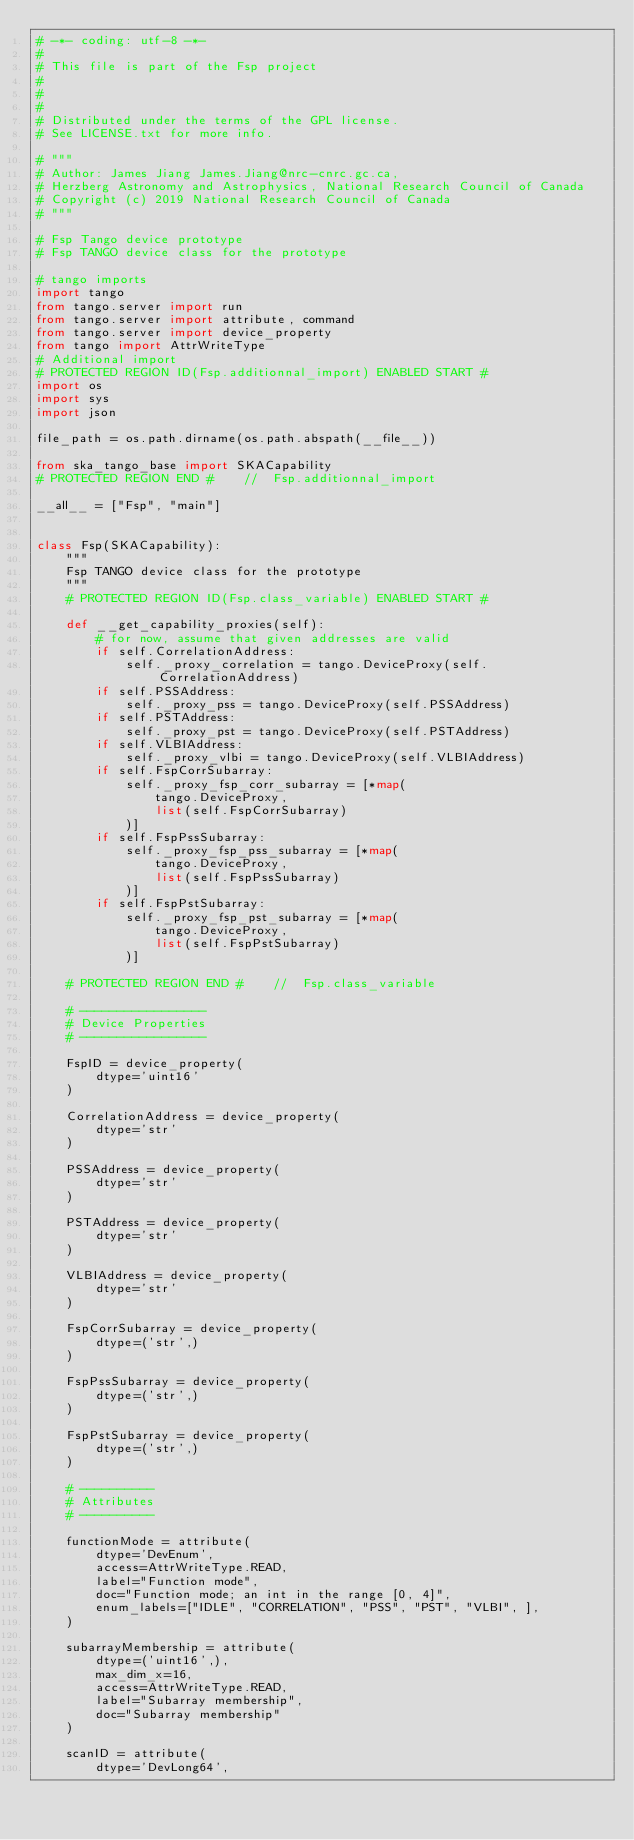Convert code to text. <code><loc_0><loc_0><loc_500><loc_500><_Python_># -*- coding: utf-8 -*-
#
# This file is part of the Fsp project
#
#
#
# Distributed under the terms of the GPL license.
# See LICENSE.txt for more info.

# """
# Author: James Jiang James.Jiang@nrc-cnrc.gc.ca,
# Herzberg Astronomy and Astrophysics, National Research Council of Canada
# Copyright (c) 2019 National Research Council of Canada
# """

# Fsp Tango device prototype
# Fsp TANGO device class for the prototype

# tango imports
import tango
from tango.server import run
from tango.server import attribute, command
from tango.server import device_property
from tango import AttrWriteType
# Additional import
# PROTECTED REGION ID(Fsp.additionnal_import) ENABLED START #
import os
import sys
import json

file_path = os.path.dirname(os.path.abspath(__file__))

from ska_tango_base import SKACapability
# PROTECTED REGION END #    //  Fsp.additionnal_import

__all__ = ["Fsp", "main"]


class Fsp(SKACapability):
    """
    Fsp TANGO device class for the prototype
    """
    # PROTECTED REGION ID(Fsp.class_variable) ENABLED START #

    def __get_capability_proxies(self):
        # for now, assume that given addresses are valid
        if self.CorrelationAddress:
            self._proxy_correlation = tango.DeviceProxy(self.CorrelationAddress)
        if self.PSSAddress:
            self._proxy_pss = tango.DeviceProxy(self.PSSAddress)
        if self.PSTAddress:
            self._proxy_pst = tango.DeviceProxy(self.PSTAddress)
        if self.VLBIAddress:
            self._proxy_vlbi = tango.DeviceProxy(self.VLBIAddress)
        if self.FspCorrSubarray:
            self._proxy_fsp_corr_subarray = [*map(
                tango.DeviceProxy,
                list(self.FspCorrSubarray)
            )]
        if self.FspPssSubarray:
            self._proxy_fsp_pss_subarray = [*map(
                tango.DeviceProxy,
                list(self.FspPssSubarray)
            )]
        if self.FspPstSubarray:
            self._proxy_fsp_pst_subarray = [*map(
                tango.DeviceProxy,
                list(self.FspPstSubarray)
            )]

    # PROTECTED REGION END #    //  Fsp.class_variable

    # -----------------
    # Device Properties
    # -----------------

    FspID = device_property(
        dtype='uint16'
    )

    CorrelationAddress = device_property(
        dtype='str'
    )

    PSSAddress = device_property(
        dtype='str'
    )

    PSTAddress = device_property(
        dtype='str'
    )

    VLBIAddress = device_property(
        dtype='str'
    )

    FspCorrSubarray = device_property(
        dtype=('str',)
    )

    FspPssSubarray = device_property(
        dtype=('str',)
    )

    FspPstSubarray = device_property(
        dtype=('str',)
    )

    # ----------
    # Attributes
    # ----------

    functionMode = attribute(
        dtype='DevEnum',
        access=AttrWriteType.READ,
        label="Function mode",
        doc="Function mode; an int in the range [0, 4]",
        enum_labels=["IDLE", "CORRELATION", "PSS", "PST", "VLBI", ],
    )

    subarrayMembership = attribute(
        dtype=('uint16',),
        max_dim_x=16,
        access=AttrWriteType.READ,
        label="Subarray membership",
        doc="Subarray membership"
    )

    scanID = attribute(
        dtype='DevLong64',</code> 